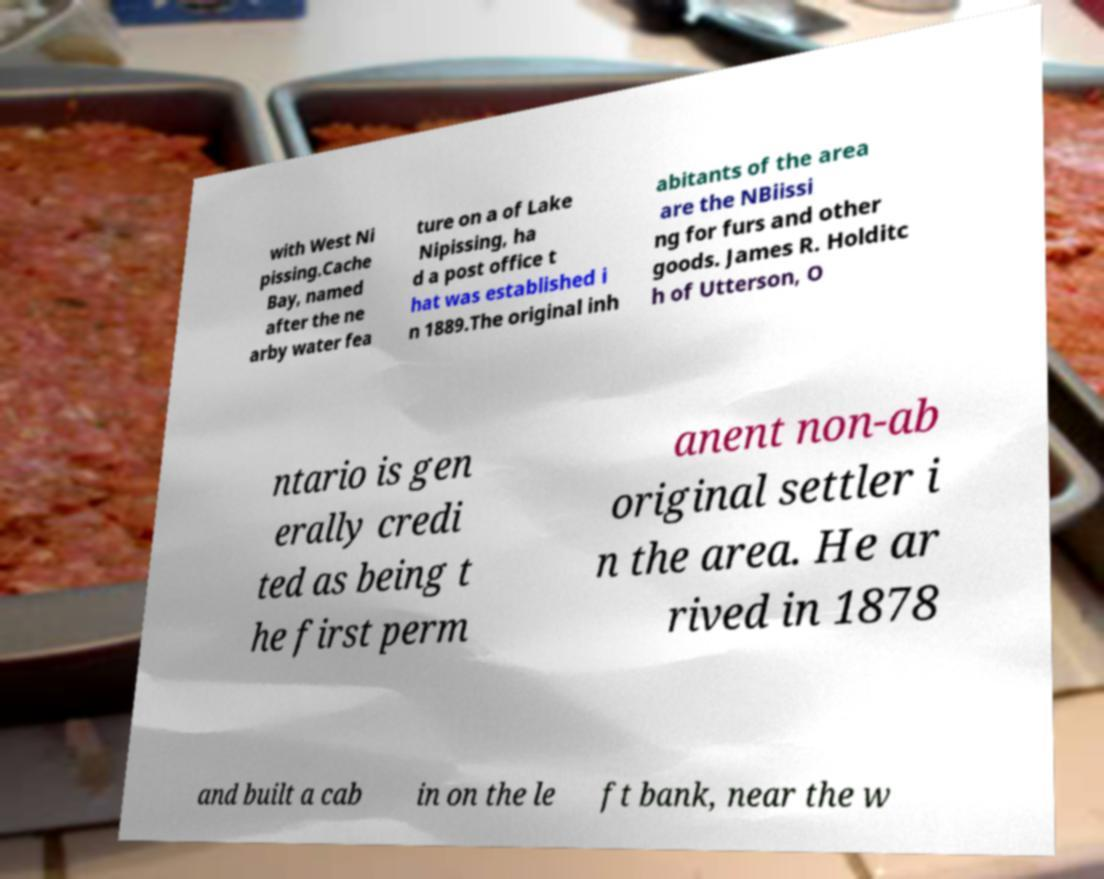What can you tell me about the original inhabitants of the area discussed in the document? The document refers to the Nibiissing as the original inhabitants of the area near Cache Bay and Lake Nipissing, who were engaged in trading furs and other goods. 